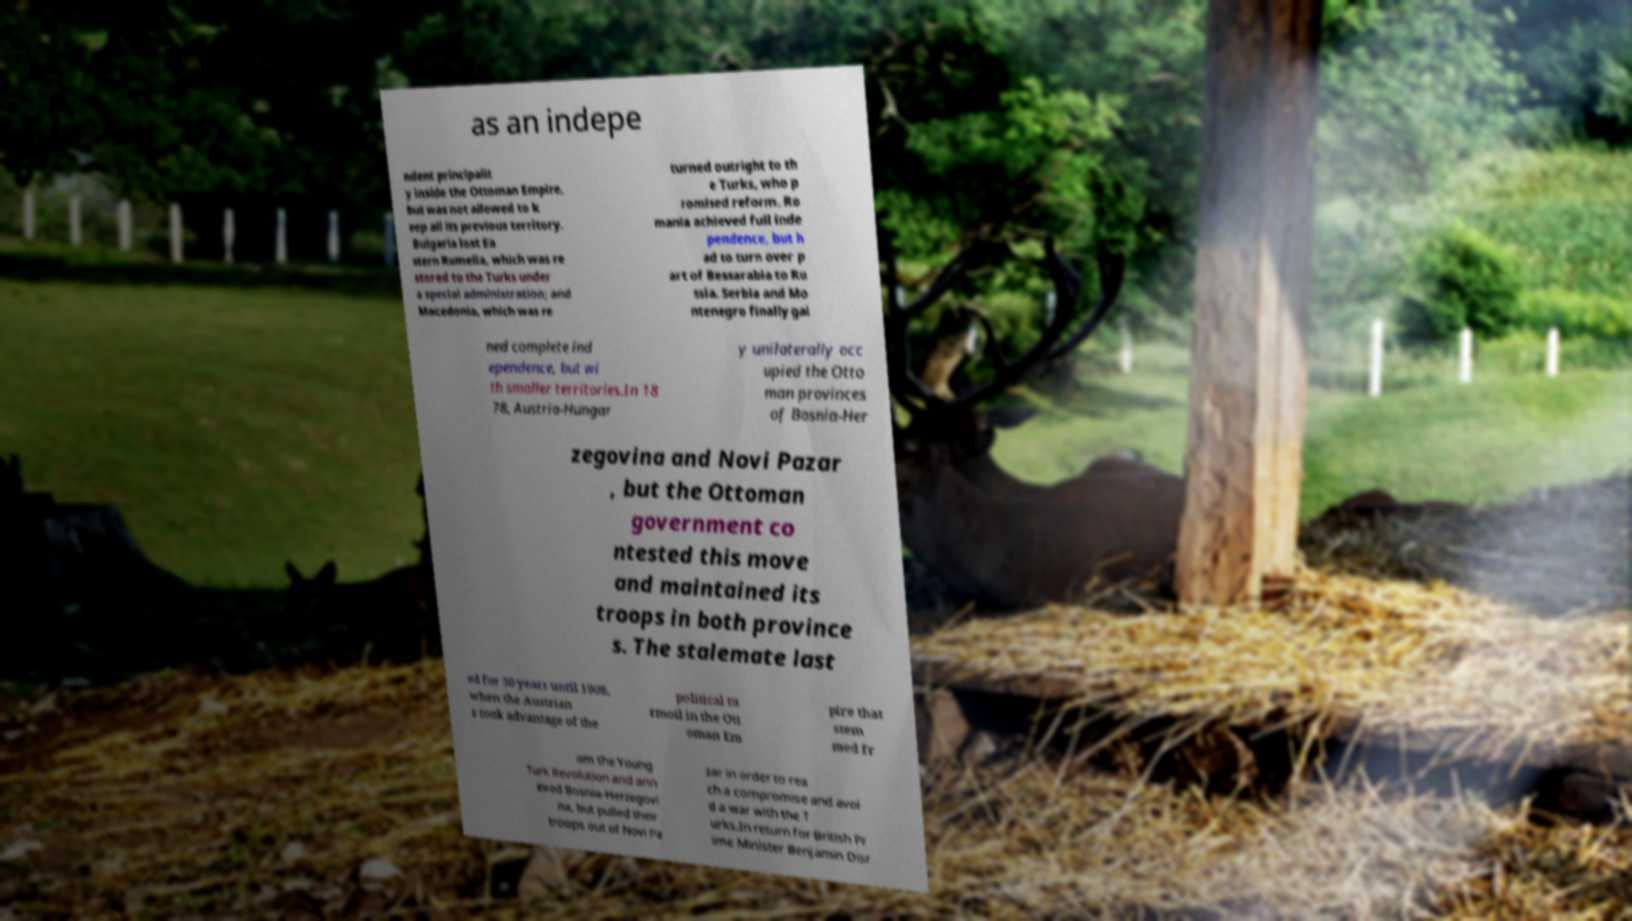I need the written content from this picture converted into text. Can you do that? as an indepe ndent principalit y inside the Ottoman Empire, but was not allowed to k eep all its previous territory. Bulgaria lost Ea stern Rumelia, which was re stored to the Turks under a special administration; and Macedonia, which was re turned outright to th e Turks, who p romised reform. Ro mania achieved full inde pendence, but h ad to turn over p art of Bessarabia to Ru ssia. Serbia and Mo ntenegro finally gai ned complete ind ependence, but wi th smaller territories.In 18 78, Austria-Hungar y unilaterally occ upied the Otto man provinces of Bosnia-Her zegovina and Novi Pazar , but the Ottoman government co ntested this move and maintained its troops in both province s. The stalemate last ed for 30 years until 1908, when the Austrian s took advantage of the political tu rmoil in the Ott oman Em pire that stem med fr om the Young Turk Revolution and ann exed Bosnia-Herzegovi na, but pulled their troops out of Novi Pa zar in order to rea ch a compromise and avoi d a war with the T urks.In return for British Pr ime Minister Benjamin Disr 